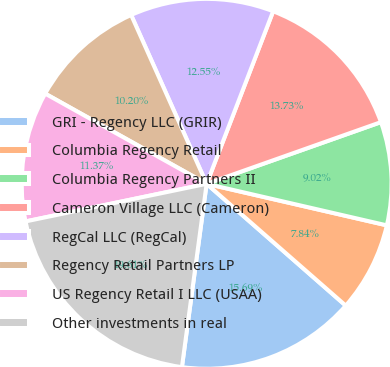Convert chart to OTSL. <chart><loc_0><loc_0><loc_500><loc_500><pie_chart><fcel>GRI - Regency LLC (GRIR)<fcel>Columbia Regency Retail<fcel>Columbia Regency Partners II<fcel>Cameron Village LLC (Cameron)<fcel>RegCal LLC (RegCal)<fcel>Regency Retail Partners LP<fcel>US Regency Retail I LLC (USAA)<fcel>Other investments in real<nl><fcel>15.69%<fcel>7.84%<fcel>9.02%<fcel>13.73%<fcel>12.55%<fcel>10.2%<fcel>11.37%<fcel>19.61%<nl></chart> 